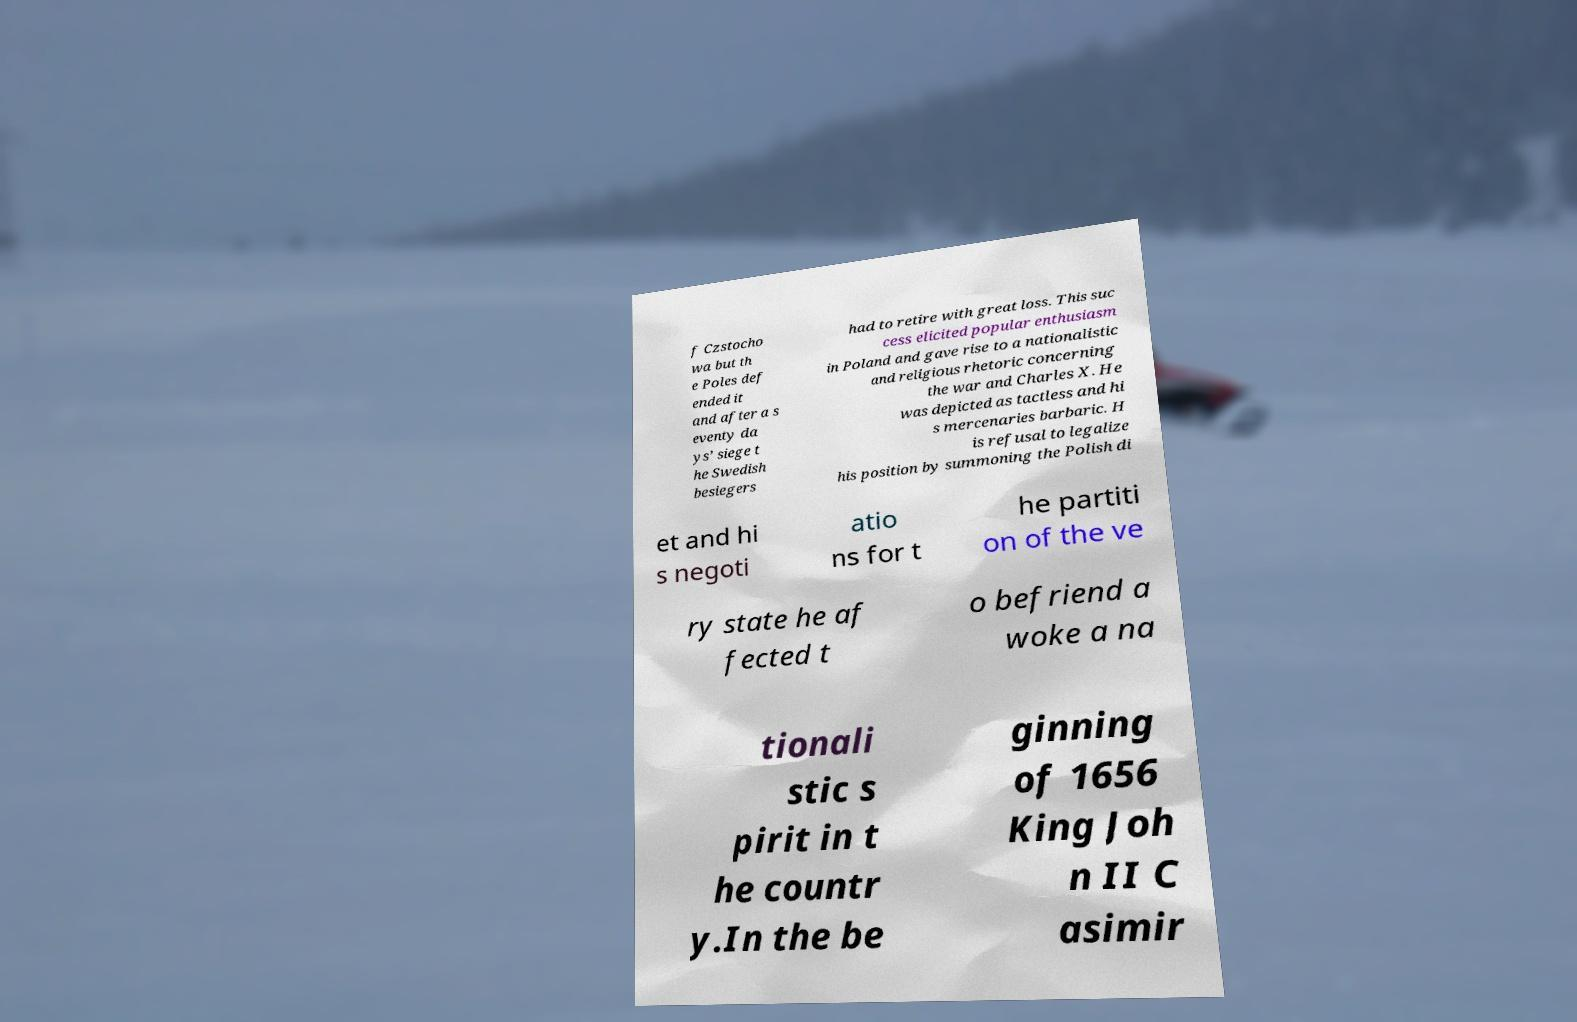What messages or text are displayed in this image? I need them in a readable, typed format. f Czstocho wa but th e Poles def ended it and after a s eventy da ys’ siege t he Swedish besiegers had to retire with great loss. This suc cess elicited popular enthusiasm in Poland and gave rise to a nationalistic and religious rhetoric concerning the war and Charles X. He was depicted as tactless and hi s mercenaries barbaric. H is refusal to legalize his position by summoning the Polish di et and hi s negoti atio ns for t he partiti on of the ve ry state he af fected t o befriend a woke a na tionali stic s pirit in t he countr y.In the be ginning of 1656 King Joh n II C asimir 